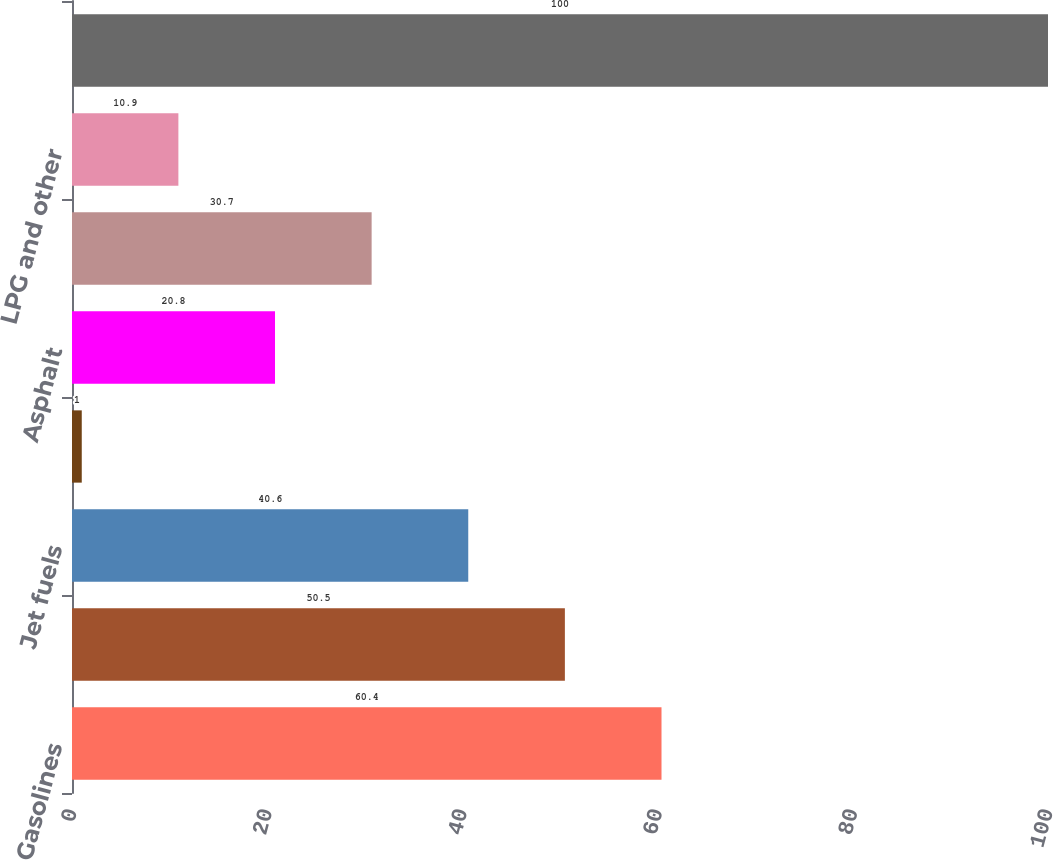<chart> <loc_0><loc_0><loc_500><loc_500><bar_chart><fcel>Gasolines<fcel>Diesel fuels<fcel>Jet fuels<fcel>Fuel oil<fcel>Asphalt<fcel>Base oils<fcel>LPG and other<fcel>Total<nl><fcel>60.4<fcel>50.5<fcel>40.6<fcel>1<fcel>20.8<fcel>30.7<fcel>10.9<fcel>100<nl></chart> 